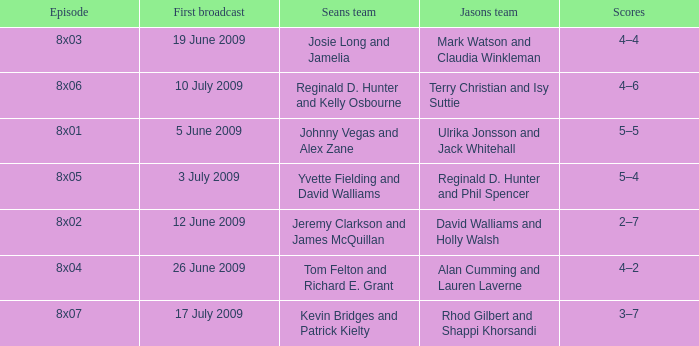Who was on Jason's team in the episode where Sean's team was Reginald D. Hunter and Kelly Osbourne? Terry Christian and Isy Suttie. 